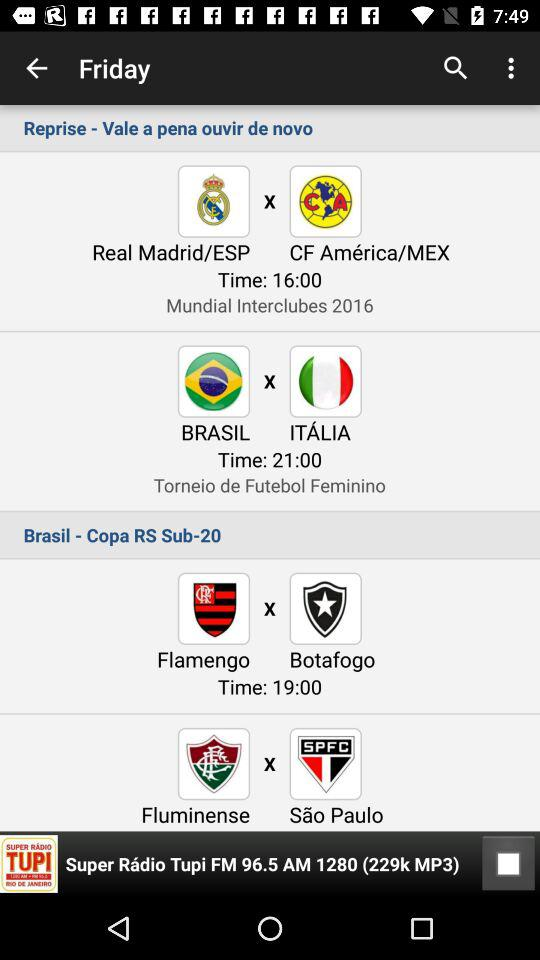What is the time of the match between Flamengo and Botafogo? Flamengo vs. Botafogo starts at 19:00. 